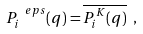<formula> <loc_0><loc_0><loc_500><loc_500>P ^ { \ e p s } _ { i } ( q ) = \overline { P ^ { K } _ { i } ( q ) } \ ,</formula> 